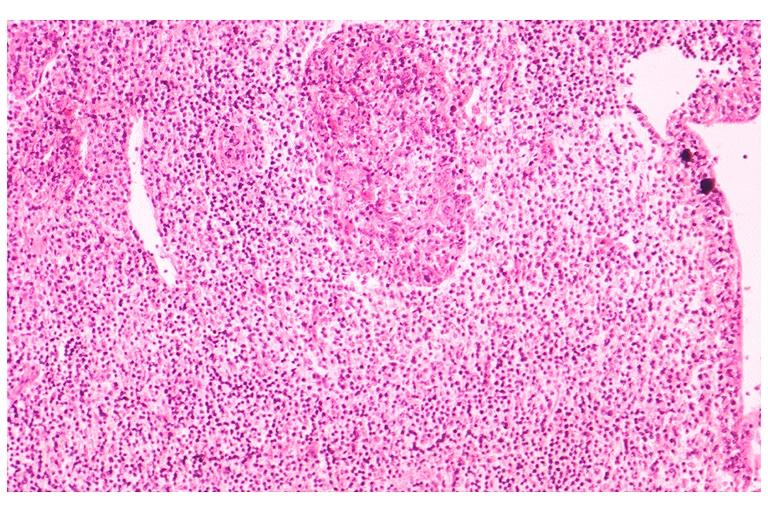does this image show sjogrens syndrome?
Answer the question using a single word or phrase. Yes 